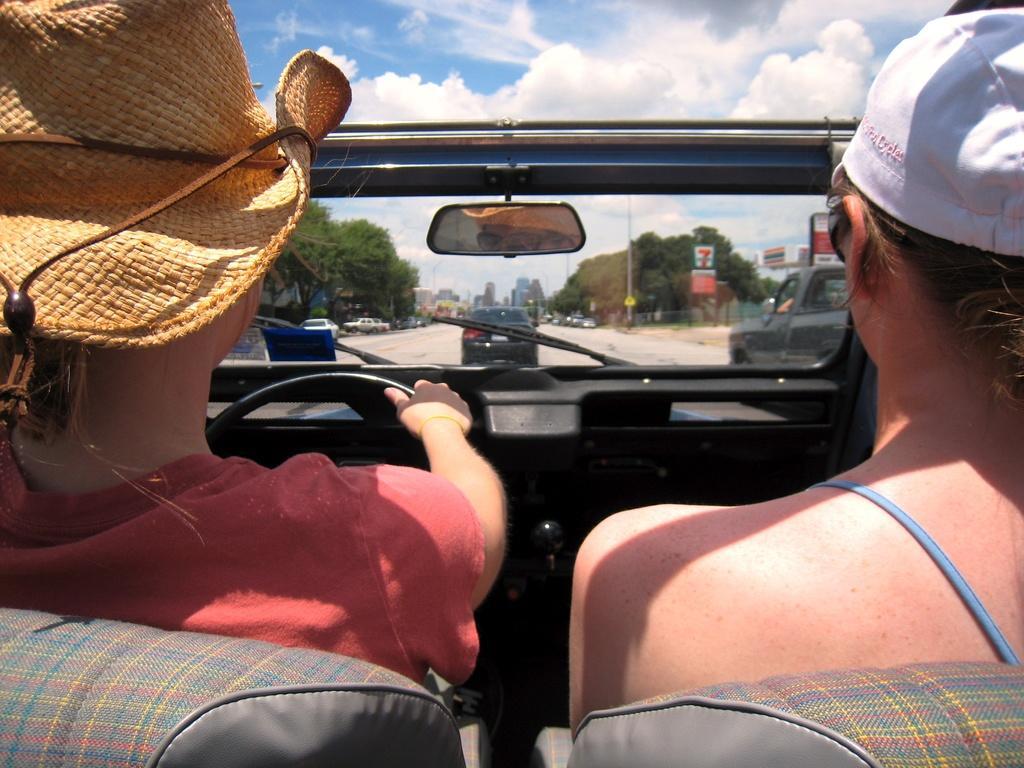How would you summarize this image in a sentence or two? In this image I can see two people are sitting in the vehicle. One person is driving the vehicle on the road. On the top of the image I can see the sky. In the background there are some trees and buildings. these both are having the caps on their heads. 